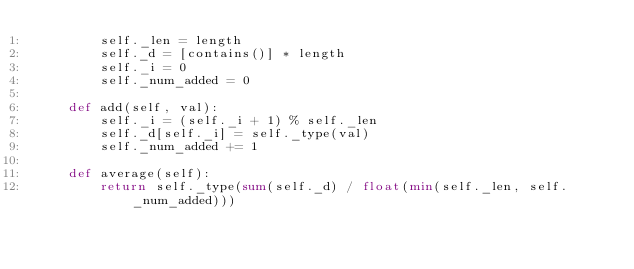<code> <loc_0><loc_0><loc_500><loc_500><_Python_>        self._len = length
        self._d = [contains()] * length
        self._i = 0
        self._num_added = 0

    def add(self, val):
        self._i = (self._i + 1) % self._len
        self._d[self._i] = self._type(val)
        self._num_added += 1

    def average(self):
        return self._type(sum(self._d) / float(min(self._len, self._num_added)))
</code> 